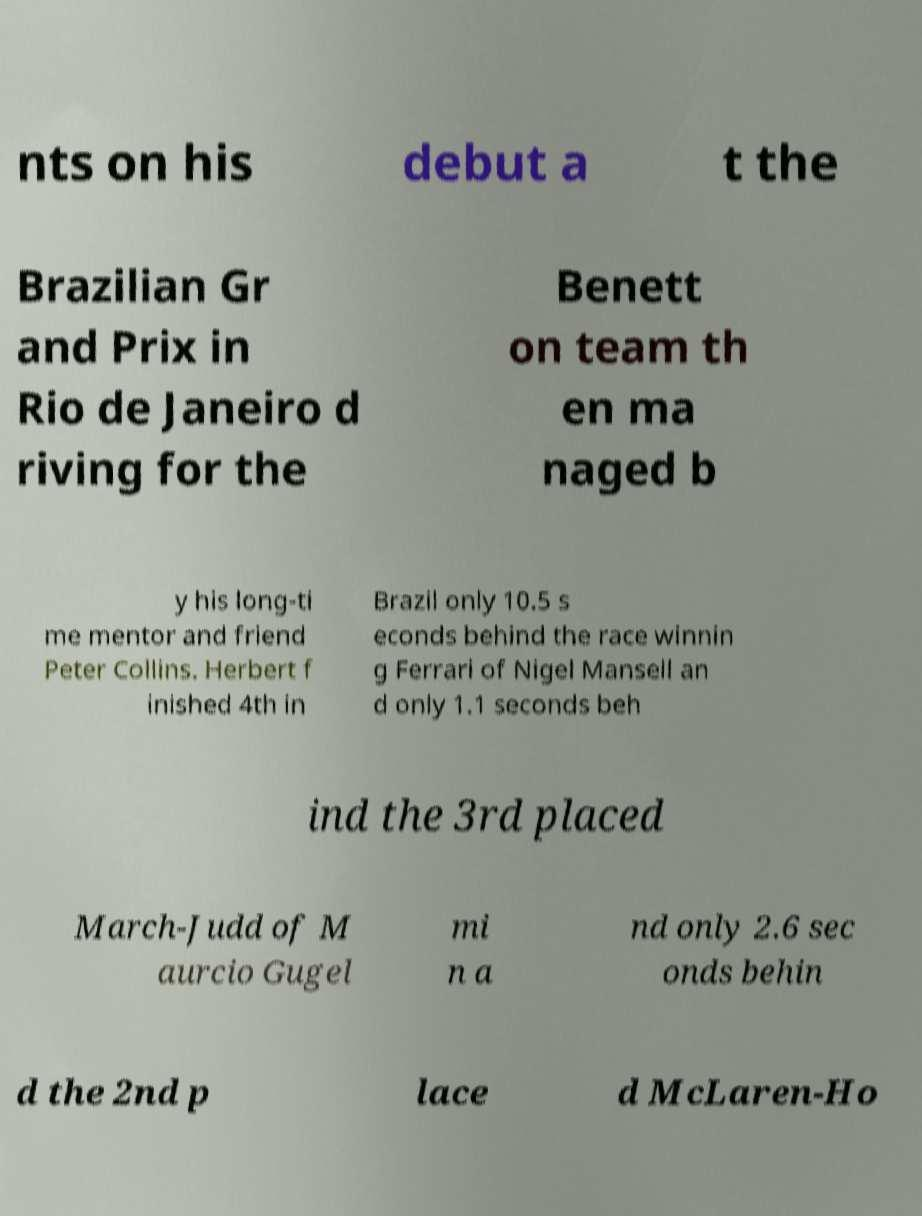Please read and relay the text visible in this image. What does it say? nts on his debut a t the Brazilian Gr and Prix in Rio de Janeiro d riving for the Benett on team th en ma naged b y his long-ti me mentor and friend Peter Collins. Herbert f inished 4th in Brazil only 10.5 s econds behind the race winnin g Ferrari of Nigel Mansell an d only 1.1 seconds beh ind the 3rd placed March-Judd of M aurcio Gugel mi n a nd only 2.6 sec onds behin d the 2nd p lace d McLaren-Ho 